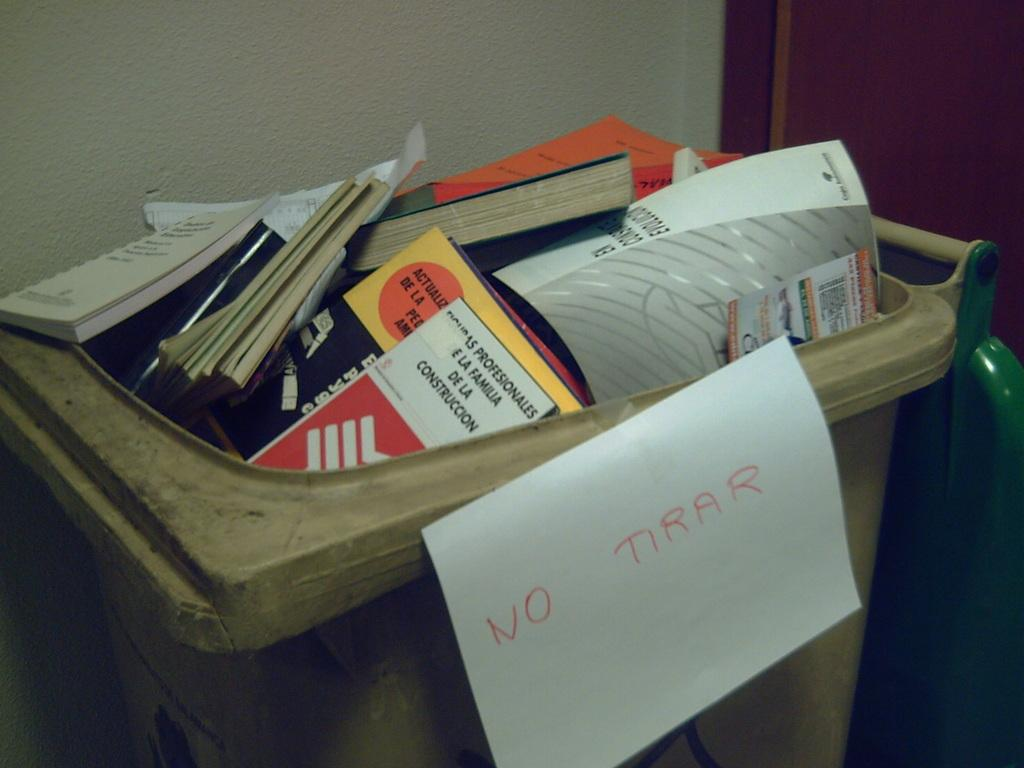What objects are present in the image? There are books in the image. How are the books stored or organized? The books are kept in a box. What can be seen behind the box in the image? There is a wall visible behind the box. What type of poison is being used to clean the books in the image? There is no poison present in the image, and the books are not being cleaned. 